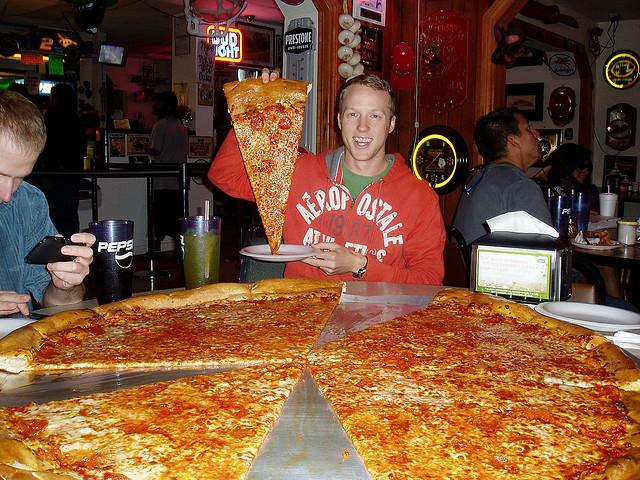Is this a meat lovers pizza?
Concise answer only. No. What beer is advertised on the wall?
Quick response, please. Bud light. Is this in someone's house?
Write a very short answer. No. 